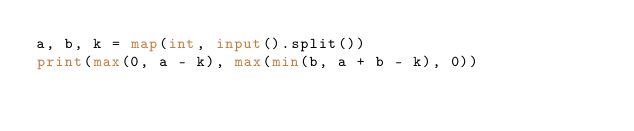Convert code to text. <code><loc_0><loc_0><loc_500><loc_500><_Python_>a, b, k = map(int, input().split())
print(max(0, a - k), max(min(b, a + b - k), 0))</code> 